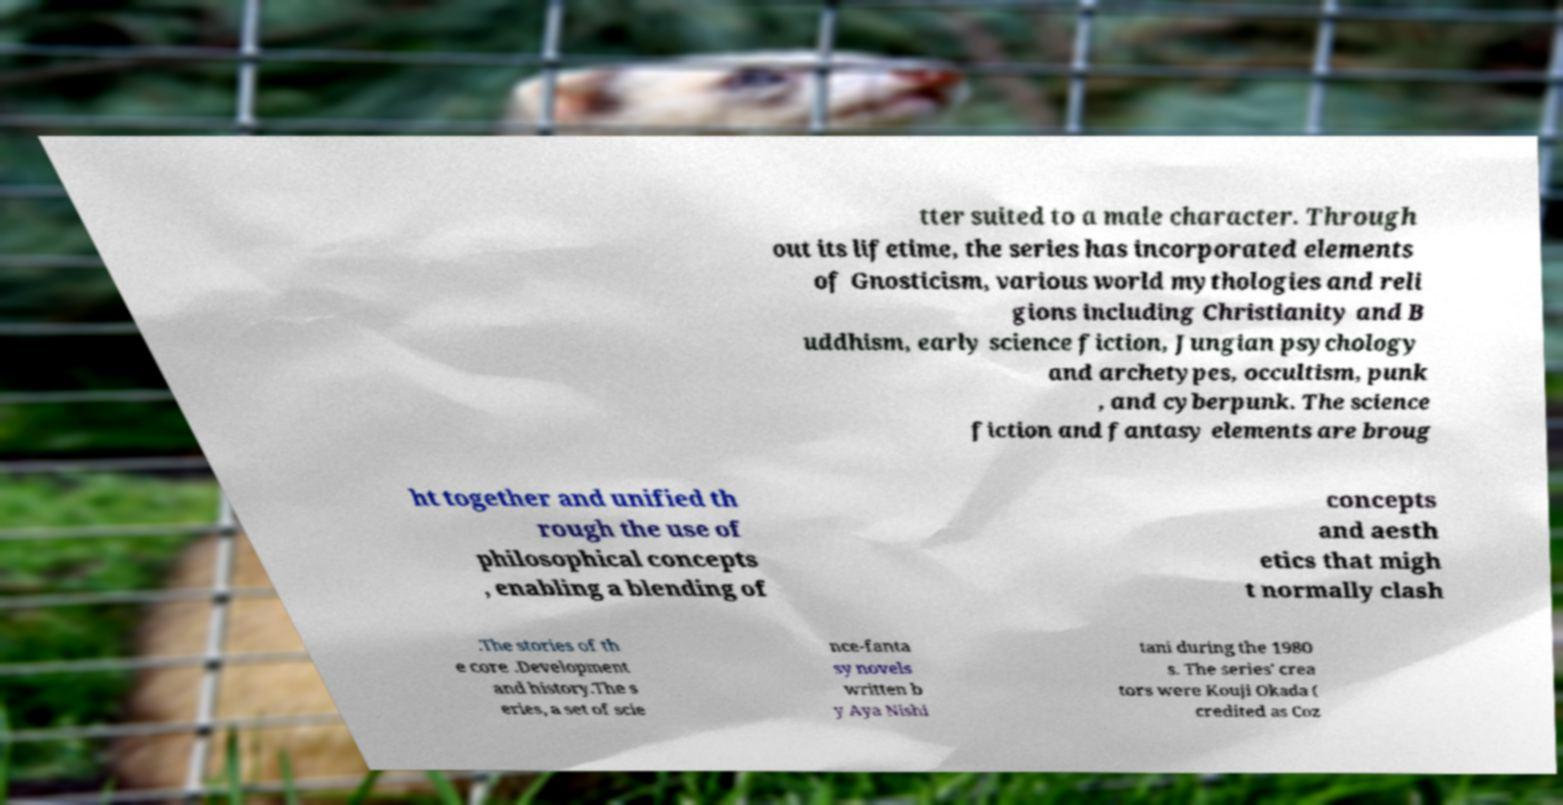Could you assist in decoding the text presented in this image and type it out clearly? tter suited to a male character. Through out its lifetime, the series has incorporated elements of Gnosticism, various world mythologies and reli gions including Christianity and B uddhism, early science fiction, Jungian psychology and archetypes, occultism, punk , and cyberpunk. The science fiction and fantasy elements are broug ht together and unified th rough the use of philosophical concepts , enabling a blending of concepts and aesth etics that migh t normally clash .The stories of th e core .Development and history.The s eries, a set of scie nce-fanta sy novels written b y Aya Nishi tani during the 1980 s. The series' crea tors were Kouji Okada ( credited as Coz 